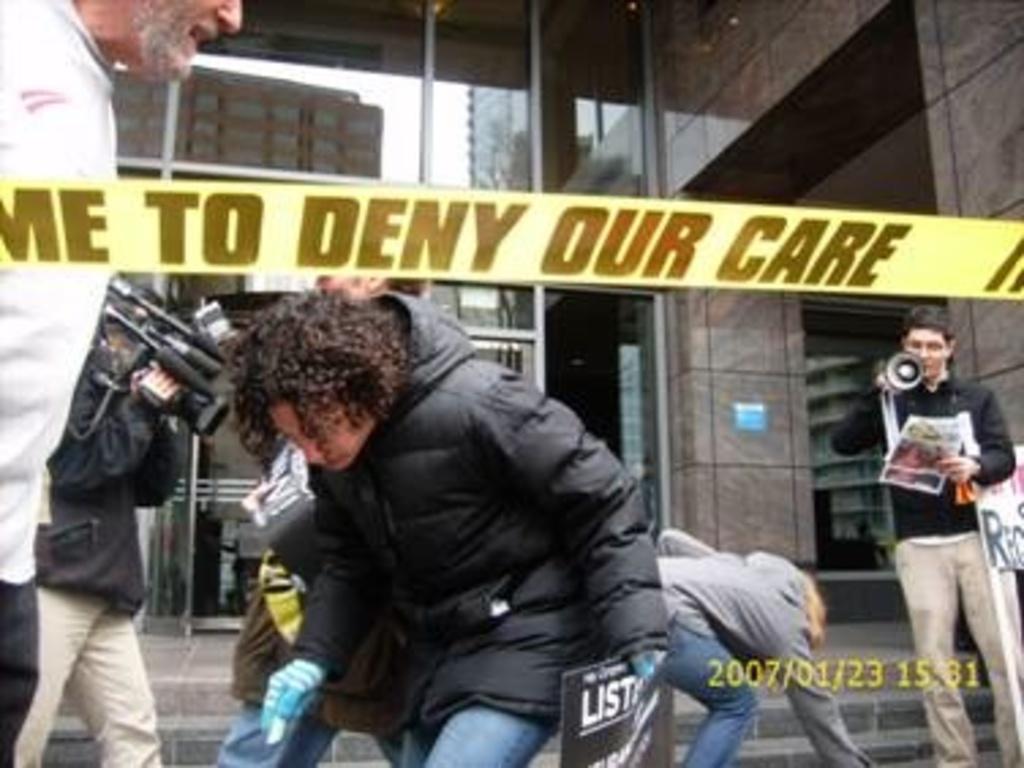Describe this image in one or two sentences. Here we can see few persons. He is holding a camera with his hands. There is a person holding papers. In the background we can see a building. 